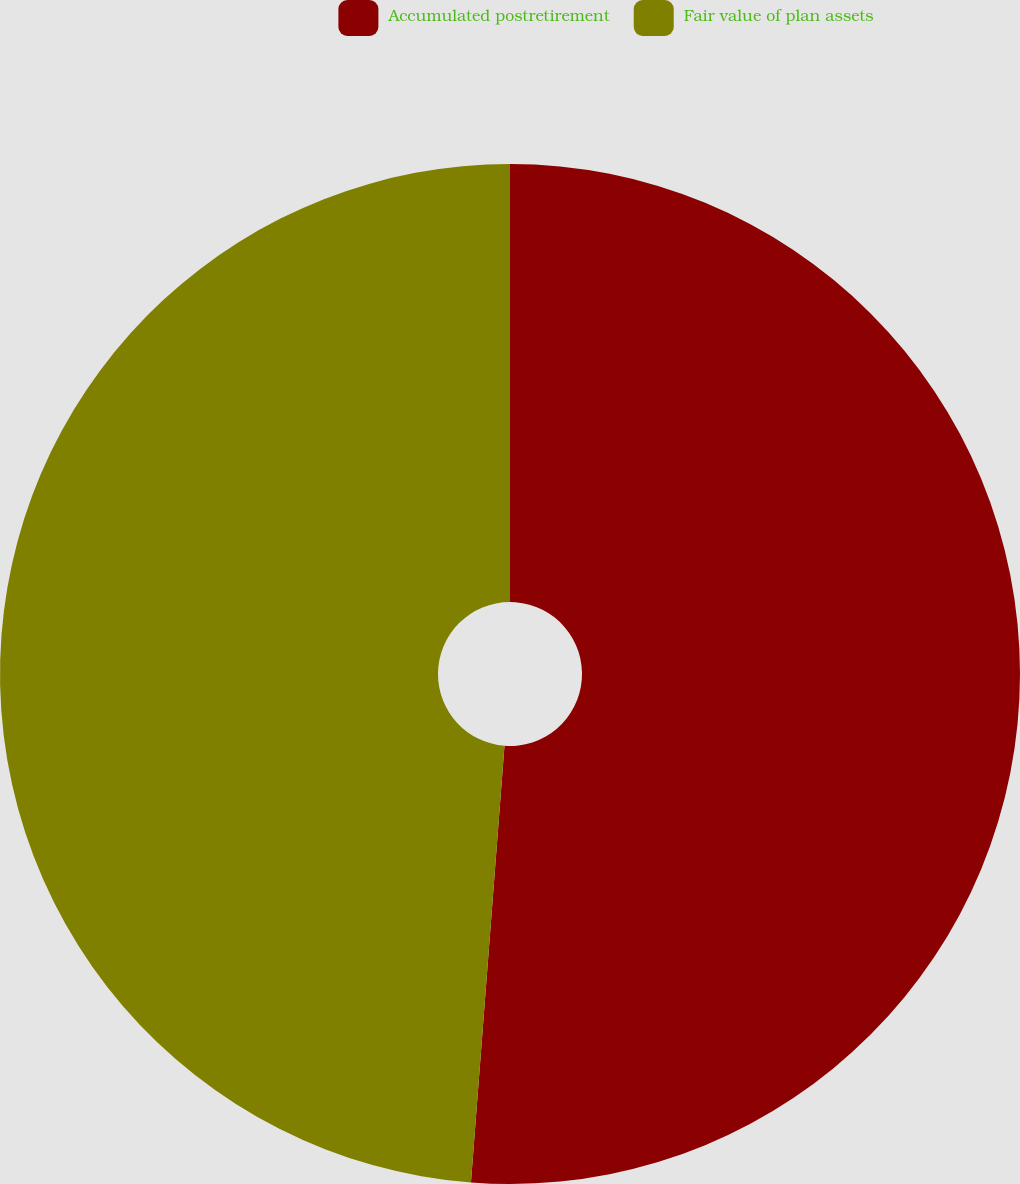Convert chart to OTSL. <chart><loc_0><loc_0><loc_500><loc_500><pie_chart><fcel>Accumulated postretirement<fcel>Fair value of plan assets<nl><fcel>51.22%<fcel>48.78%<nl></chart> 